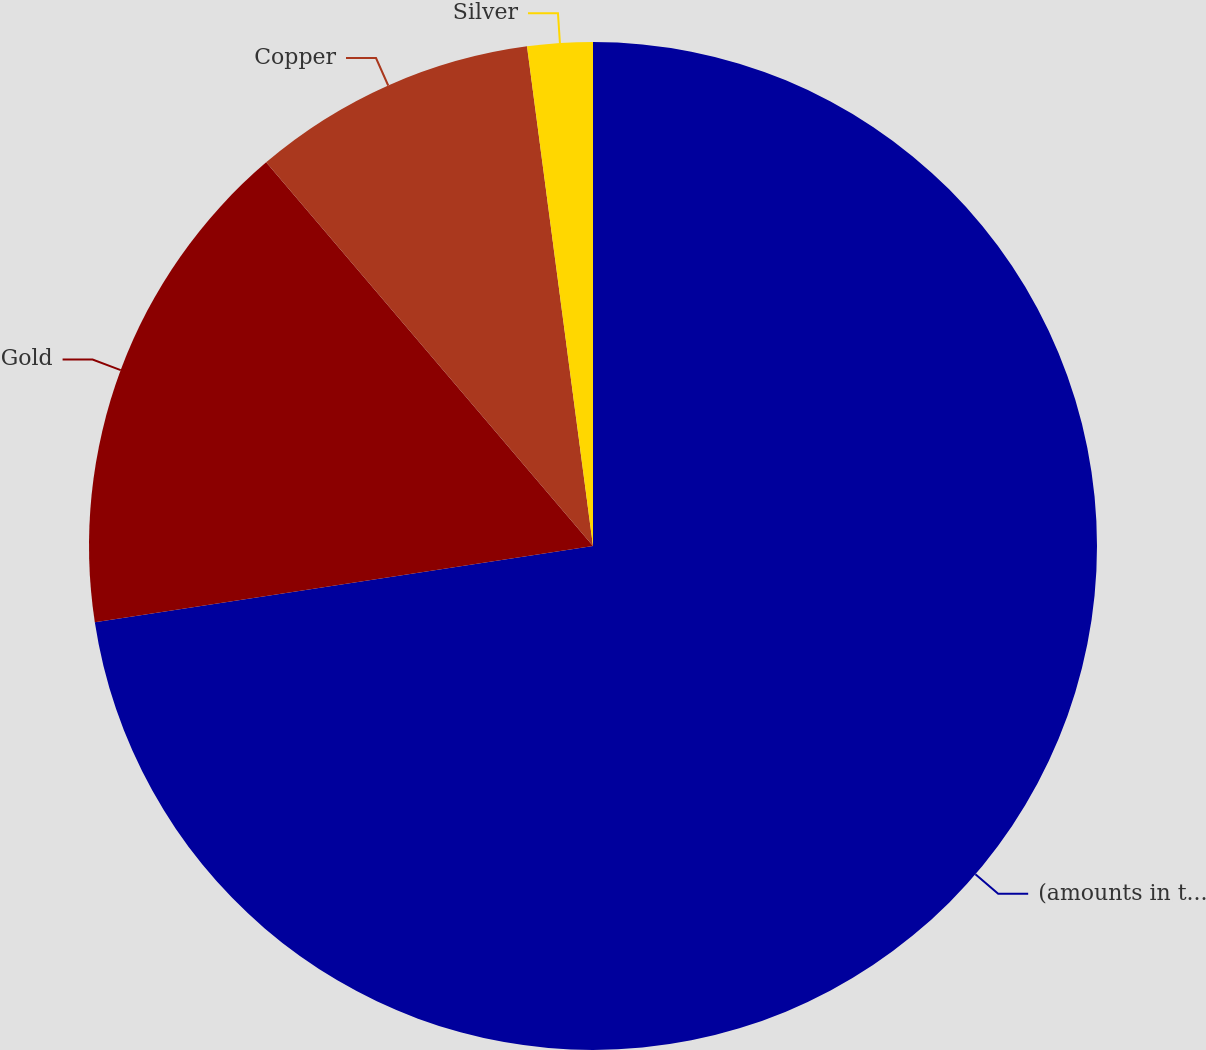Convert chart. <chart><loc_0><loc_0><loc_500><loc_500><pie_chart><fcel>(amounts in thousands)<fcel>Gold<fcel>Copper<fcel>Silver<nl><fcel>72.58%<fcel>16.19%<fcel>9.14%<fcel>2.09%<nl></chart> 